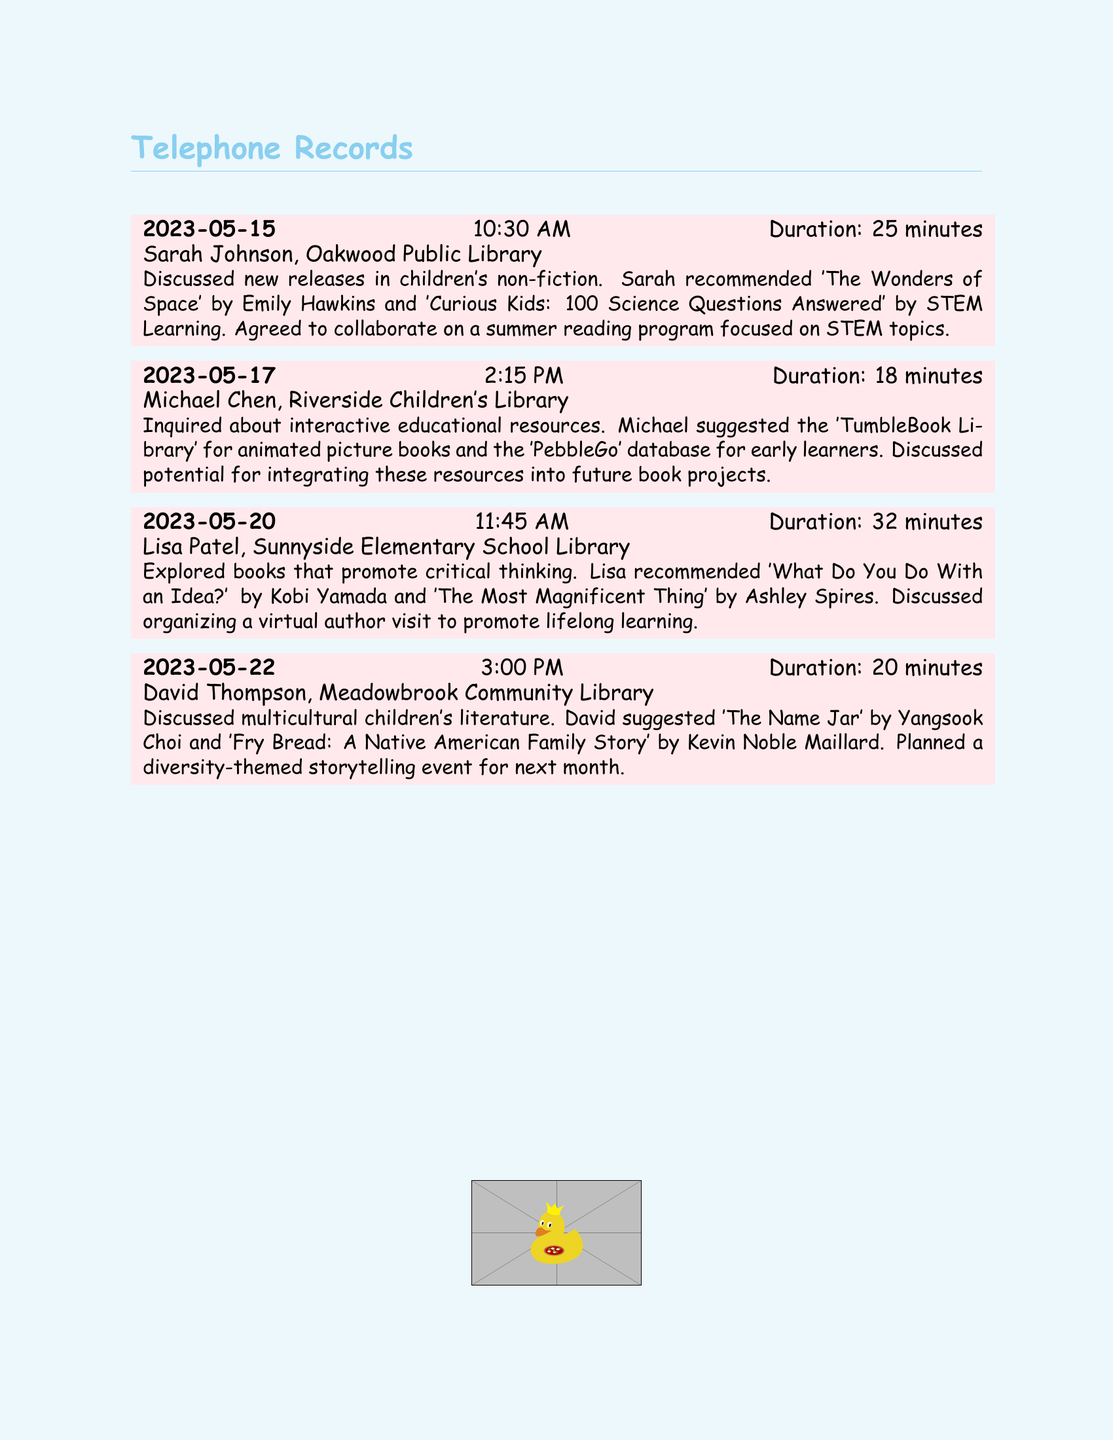What was the date of the call with Sarah Johnson? The date of the call with Sarah Johnson is mentioned in the entry provided in the document.
Answer: 2023-05-15 How long was the conversation with Michael Chen? The duration of the conversation with Michael Chen is specified in the call log.
Answer: 18 minutes What book did Lisa Patel recommend? The document lists the book recommendations given by Lisa Patel in her entry.
Answer: What Do You Do With an Idea? Which library did David Thompson represent? David Thompson's affiliation is noted in the call entry about multicultural literature.
Answer: Meadowbrook Community Library What educational resource did Michael suggest? The call log details the educational resource recommended by Michael Chen.
Answer: TumbleBook Library Who is the author of 'The Most Magnificent Thing'? The author of the book mentioned by Lisa Patel is provided in the conversation notes.
Answer: Ashley Spires What theme was planned for next month’s storytelling event? The theme for the upcoming event is described in David Thompson's entry.
Answer: Diversity How many librarians were consulted in total? The number of entries in the record indicates how many librarians were consulted.
Answer: Four What is the focus of the summer reading program discussed with Sarah? The focus of the collaboration is highlighted in the conversation with Sarah Johnson.
Answer: STEM topics 